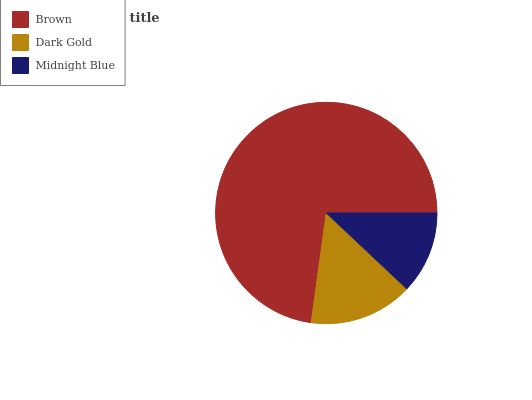Is Midnight Blue the minimum?
Answer yes or no. Yes. Is Brown the maximum?
Answer yes or no. Yes. Is Dark Gold the minimum?
Answer yes or no. No. Is Dark Gold the maximum?
Answer yes or no. No. Is Brown greater than Dark Gold?
Answer yes or no. Yes. Is Dark Gold less than Brown?
Answer yes or no. Yes. Is Dark Gold greater than Brown?
Answer yes or no. No. Is Brown less than Dark Gold?
Answer yes or no. No. Is Dark Gold the high median?
Answer yes or no. Yes. Is Dark Gold the low median?
Answer yes or no. Yes. Is Brown the high median?
Answer yes or no. No. Is Brown the low median?
Answer yes or no. No. 